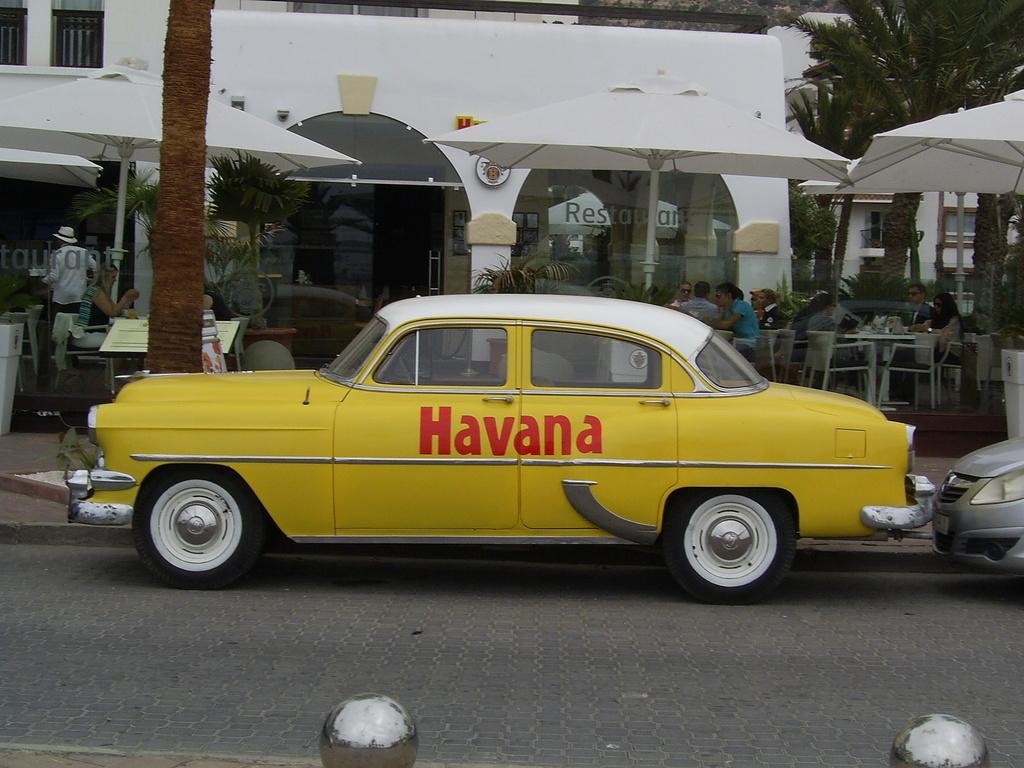<image>
Describe the image concisely. An old fashioned yellow car that says Havana is parked on the side of a street. 